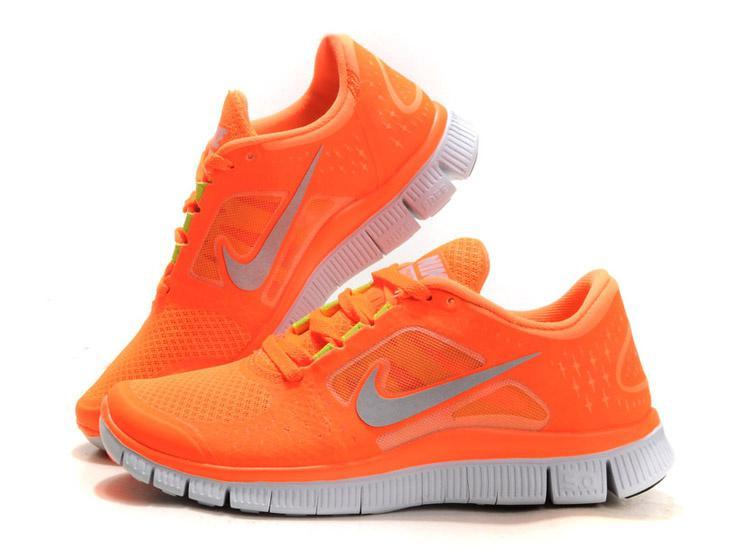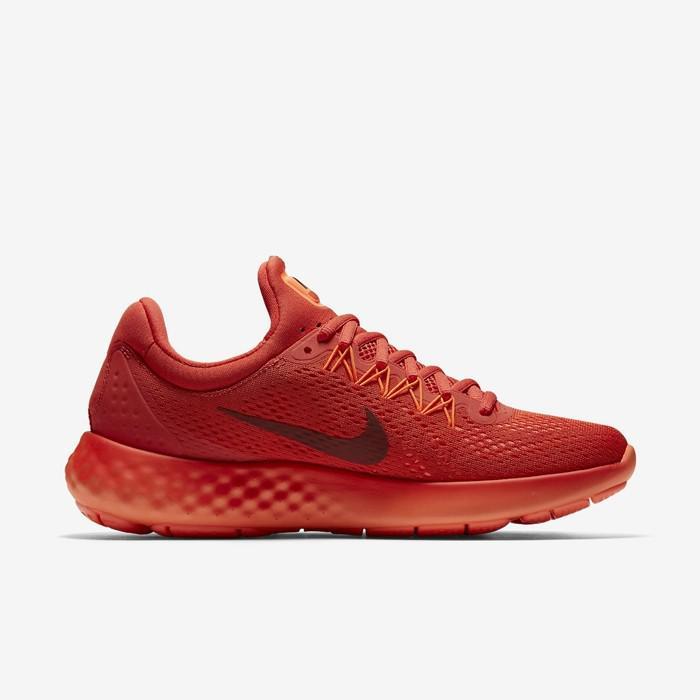The first image is the image on the left, the second image is the image on the right. For the images shown, is this caption "One image shows a pair of sneakers, with one shoe posed with the sole facing the camera and the other shoe pointed rightward, and the other image shows a single sneaker turned leftward." true? Answer yes or no. No. The first image is the image on the left, the second image is the image on the right. For the images shown, is this caption "The right image contains no more than one shoe." true? Answer yes or no. Yes. 